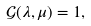<formula> <loc_0><loc_0><loc_500><loc_500>\mathcal { G } ( \lambda , \mu ) = 1 ,</formula> 